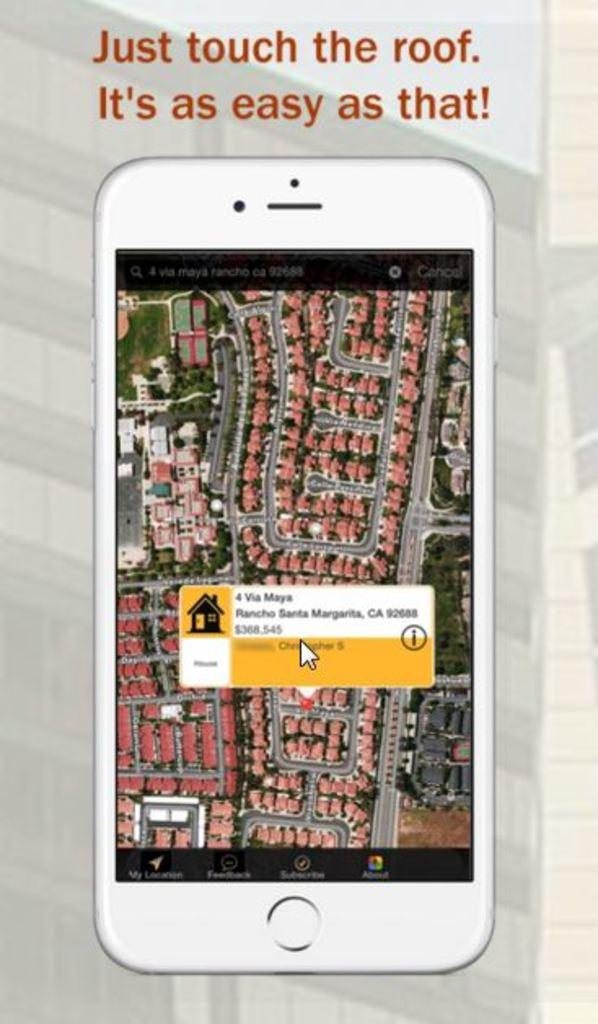Provide a one-sentence caption for the provided image. 4 Via Maya in Rancho Santa Margarita, California can be purchased for $368,545. 